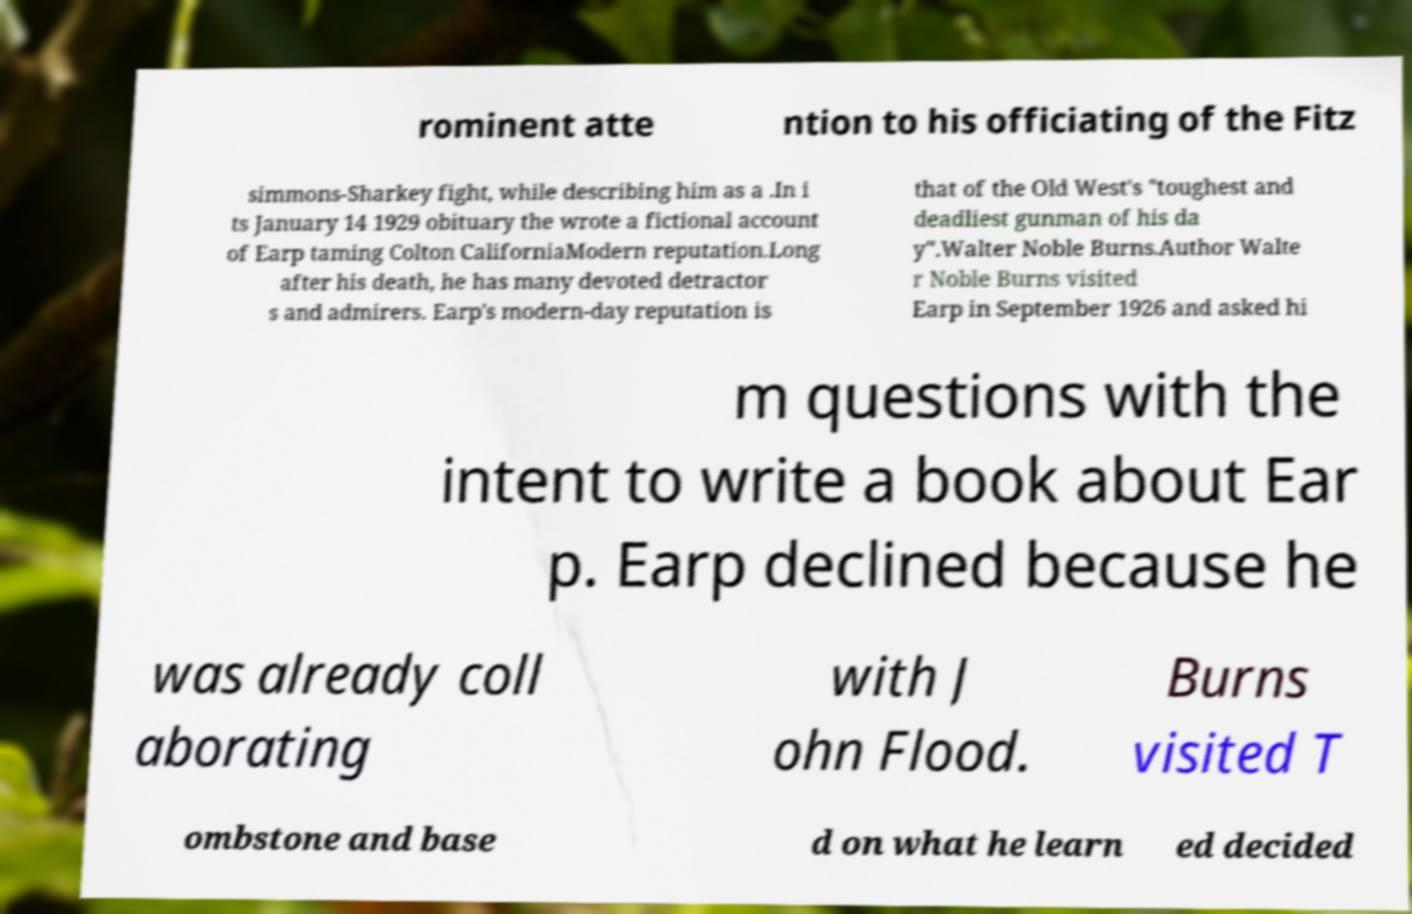Could you assist in decoding the text presented in this image and type it out clearly? rominent atte ntion to his officiating of the Fitz simmons-Sharkey fight, while describing him as a .In i ts January 14 1929 obituary the wrote a fictional account of Earp taming Colton CaliforniaModern reputation.Long after his death, he has many devoted detractor s and admirers. Earp's modern-day reputation is that of the Old West's "toughest and deadliest gunman of his da y".Walter Noble Burns.Author Walte r Noble Burns visited Earp in September 1926 and asked hi m questions with the intent to write a book about Ear p. Earp declined because he was already coll aborating with J ohn Flood. Burns visited T ombstone and base d on what he learn ed decided 